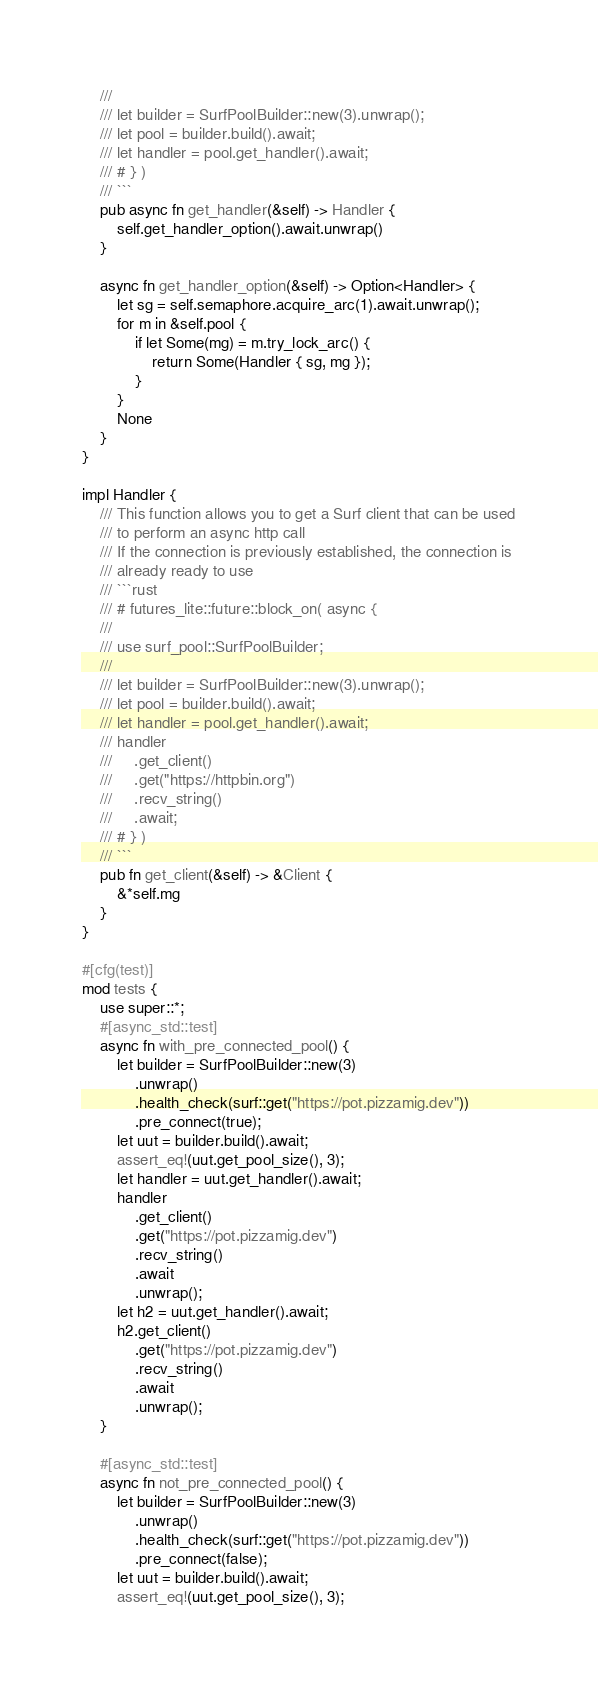<code> <loc_0><loc_0><loc_500><loc_500><_Rust_>    ///
    /// let builder = SurfPoolBuilder::new(3).unwrap();
    /// let pool = builder.build().await;
    /// let handler = pool.get_handler().await;
    /// # } )
    /// ```
    pub async fn get_handler(&self) -> Handler {
        self.get_handler_option().await.unwrap()
    }

    async fn get_handler_option(&self) -> Option<Handler> {
        let sg = self.semaphore.acquire_arc(1).await.unwrap();
        for m in &self.pool {
            if let Some(mg) = m.try_lock_arc() {
                return Some(Handler { sg, mg });
            }
        }
        None
    }
}

impl Handler {
    /// This function allows you to get a Surf client that can be used
    /// to perform an async http call
    /// If the connection is previously established, the connection is
    /// already ready to use
    /// ```rust
    /// # futures_lite::future::block_on( async {
    ///
    /// use surf_pool::SurfPoolBuilder;
    ///
    /// let builder = SurfPoolBuilder::new(3).unwrap();
    /// let pool = builder.build().await;
    /// let handler = pool.get_handler().await;
    /// handler
    ///     .get_client()
    ///     .get("https://httpbin.org")
    ///     .recv_string()
    ///     .await;
    /// # } )
    /// ```
    pub fn get_client(&self) -> &Client {
        &*self.mg
    }
}

#[cfg(test)]
mod tests {
    use super::*;
    #[async_std::test]
    async fn with_pre_connected_pool() {
        let builder = SurfPoolBuilder::new(3)
            .unwrap()
            .health_check(surf::get("https://pot.pizzamig.dev"))
            .pre_connect(true);
        let uut = builder.build().await;
        assert_eq!(uut.get_pool_size(), 3);
        let handler = uut.get_handler().await;
        handler
            .get_client()
            .get("https://pot.pizzamig.dev")
            .recv_string()
            .await
            .unwrap();
        let h2 = uut.get_handler().await;
        h2.get_client()
            .get("https://pot.pizzamig.dev")
            .recv_string()
            .await
            .unwrap();
    }

    #[async_std::test]
    async fn not_pre_connected_pool() {
        let builder = SurfPoolBuilder::new(3)
            .unwrap()
            .health_check(surf::get("https://pot.pizzamig.dev"))
            .pre_connect(false);
        let uut = builder.build().await;
        assert_eq!(uut.get_pool_size(), 3);</code> 